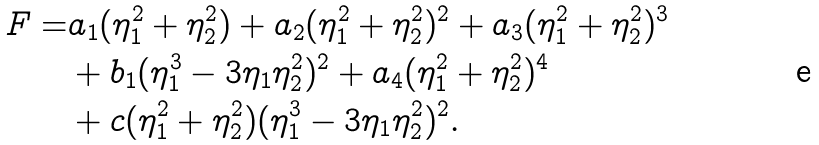Convert formula to latex. <formula><loc_0><loc_0><loc_500><loc_500>F = & a _ { 1 } ( \eta _ { 1 } ^ { 2 } + \eta _ { 2 } ^ { 2 } ) + a _ { 2 } ( \eta _ { 1 } ^ { 2 } + \eta _ { 2 } ^ { 2 } ) ^ { 2 } + a _ { 3 } ( \eta _ { 1 } ^ { 2 } + \eta _ { 2 } ^ { 2 } ) ^ { 3 } \\ & + b _ { 1 } ( \eta _ { 1 } ^ { 3 } - 3 \eta _ { 1 } \eta _ { 2 } ^ { 2 } ) ^ { 2 } + a _ { 4 } ( \eta _ { 1 } ^ { 2 } + \eta _ { 2 } ^ { 2 } ) ^ { 4 } \\ & + c ( \eta _ { 1 } ^ { 2 } + \eta _ { 2 } ^ { 2 } ) ( \eta _ { 1 } ^ { 3 } - 3 \eta _ { 1 } \eta _ { 2 } ^ { 2 } ) ^ { 2 } .</formula> 